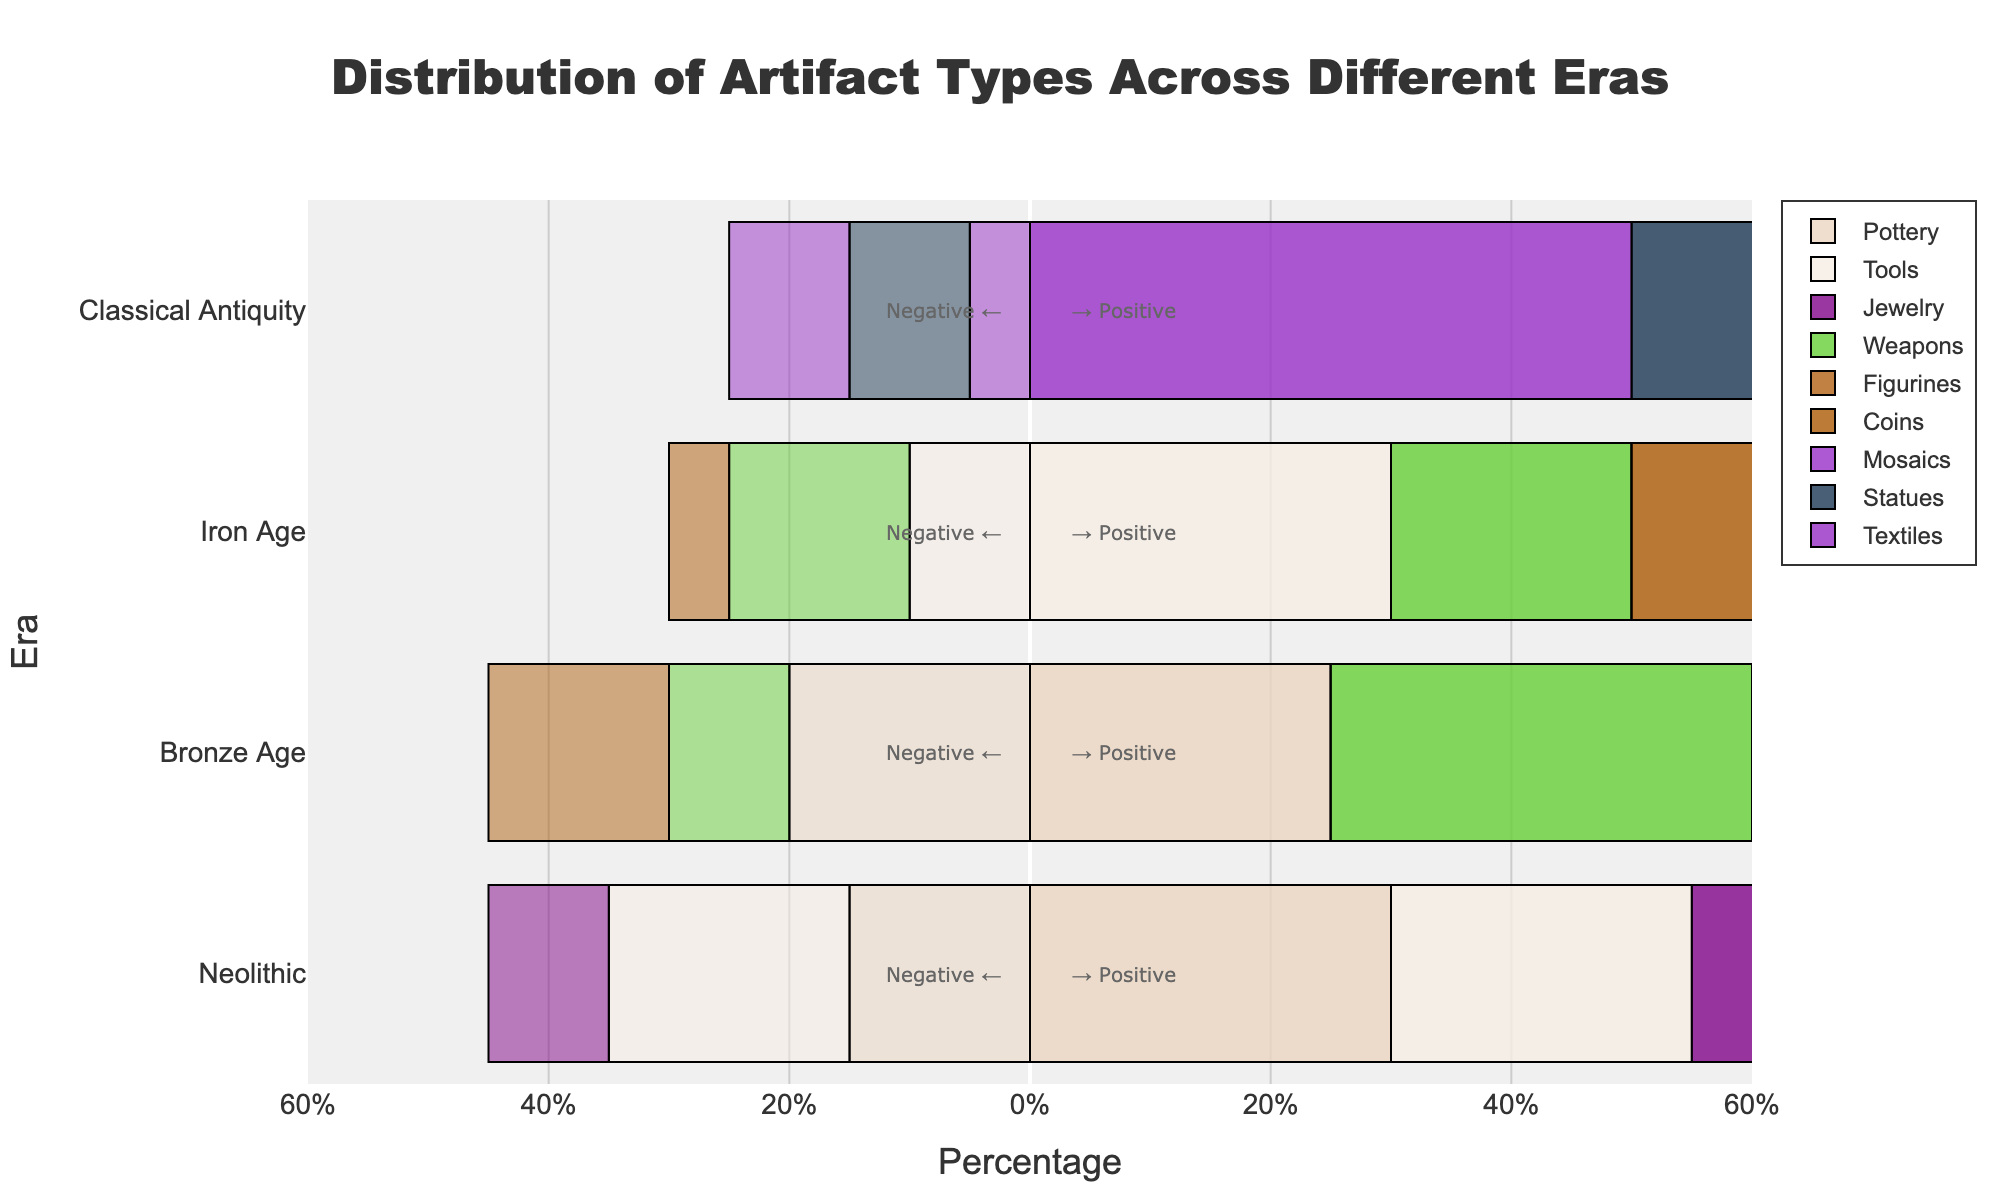Which era has the highest positive percentage for any artifact type? In the chart, Classical Antiquity shows the highest positive percentage for Mosaics at 50%.
Answer: Classical Antiquity How does the positive percentage of Tools in the Neolithic era compare to that in the Iron Age? The Neolithic era has a positive percentage of 25% for Tools, while the Iron Age has a 30% positive percentage for Tools. The Iron Age has a higher percentage.
Answer: Tools in the Iron Age have a higher positive percentage What is the difference in the positive percentage between the highest and lowest artifact types in the Iron Age? In the Iron Age, Coins have the highest positive percentage at 40%, and Weapons have the lowest at 20%. The difference is 40% - 20% = 20%.
Answer: 20% What is the sum of the positive and negative percentages for Pottery in the Bronze Age? The Bronze Age shows a 25% positive and 20% negative percentage for Pottery. The sum is 25% + 20% = 45%.
Answer: 45% Which artifact type has the closest positive percentage to 30% in any era, and what era is it? The closest positive percentages to 30% are Tools in the Neolithic era and in the Iron Age, each at 30%.
Answer: Tools in the Neolithic and Iron Age What is the average positive percentage of Artifacts in Classical Antiquity? Classical Antiquity shows: Mosaics (50%), Statues (35%), and Textiles (25%). The average is (50% + 35% + 25%) / 3 = 36.67%.
Answer: 36.67% How does the negative percentage of Jewelry in the Neolithic era compare to that of Figurines in the Bronze Age? The Neolithic era has a negative percentage of 10% for Jewelry, while the Bronze Age has a 15% negative percentage for Figurines. The Bronze Age has a higher negative percentage.
Answer: Figurines in the Bronze Age have a higher negative percentage Which era has the widest range of positive percentages for different artifact types? Classical Antiquity shows the widest range with Mosaics at 50%, Statues at 35%, and Textiles at 25%, yielding a range of 50% - 25% = 25%.
Answer: Classical Antiquity What is the combined positive percentage of all artifact types in the Bronze Age? The Bronze Age shows positive percentages for Weapons (35%), Pottery (25%), and Figurines (20%). The combined percentage is 35% + 25% + 20% = 80%.
Answer: 80% How many artifact types in any era have both their positive and negative percentages less than 20%? In the Iron Age, Coins (Positive: 40%, Negative: 5%) and Tools (Positive: 30%, Negative: 10%) both have negative percentages below 20%, but not positive. In Classical Antiquity, Textiles have 25% positive, 10% negative. Thus, none satisfy both conditions.
Answer: 0 